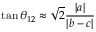Convert formula to latex. <formula><loc_0><loc_0><loc_500><loc_500>\tan \theta _ { 1 2 } \approx { \sqrt { 2 } \frac { | a | } { | b - c | } }</formula> 